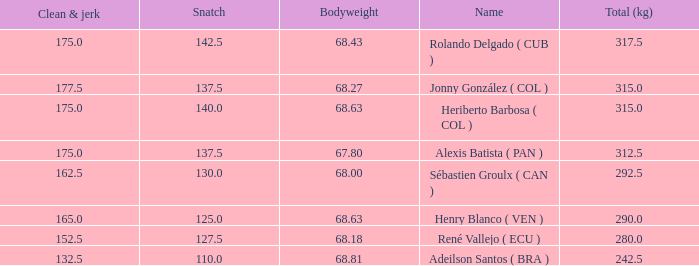Tell me the total number of snatches for clean and jerk more than 132.5 when the total kg was 315 and bodyweight was 68.63 1.0. 